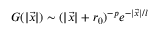<formula> <loc_0><loc_0><loc_500><loc_500>G ( | \vec { x } | ) \sim ( | \vec { x } | + r _ { 0 } ) ^ { - p } e ^ { - | \vec { x } | / l }</formula> 